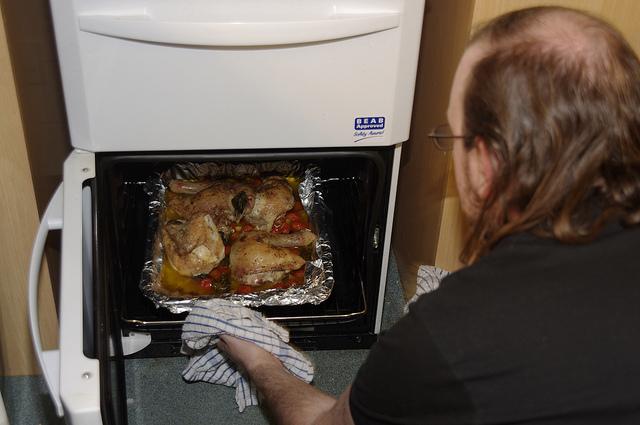What color is his shirt?
Answer briefly. Black. What color is the oven?
Quick response, please. White. What is being cooked?
Write a very short answer. Chicken. 